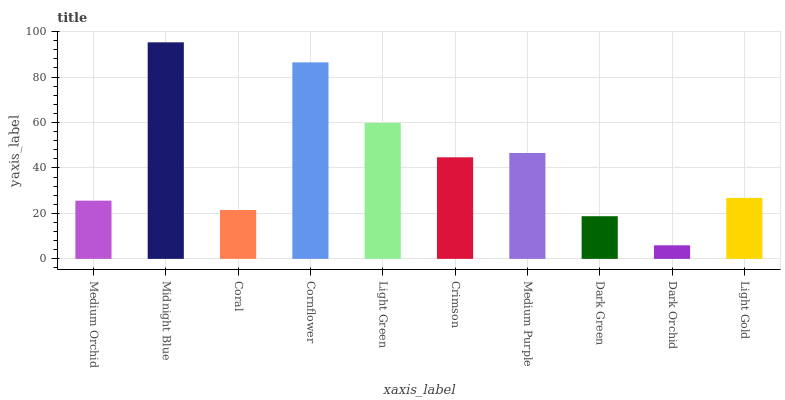Is Dark Orchid the minimum?
Answer yes or no. Yes. Is Midnight Blue the maximum?
Answer yes or no. Yes. Is Coral the minimum?
Answer yes or no. No. Is Coral the maximum?
Answer yes or no. No. Is Midnight Blue greater than Coral?
Answer yes or no. Yes. Is Coral less than Midnight Blue?
Answer yes or no. Yes. Is Coral greater than Midnight Blue?
Answer yes or no. No. Is Midnight Blue less than Coral?
Answer yes or no. No. Is Crimson the high median?
Answer yes or no. Yes. Is Light Gold the low median?
Answer yes or no. Yes. Is Midnight Blue the high median?
Answer yes or no. No. Is Cornflower the low median?
Answer yes or no. No. 